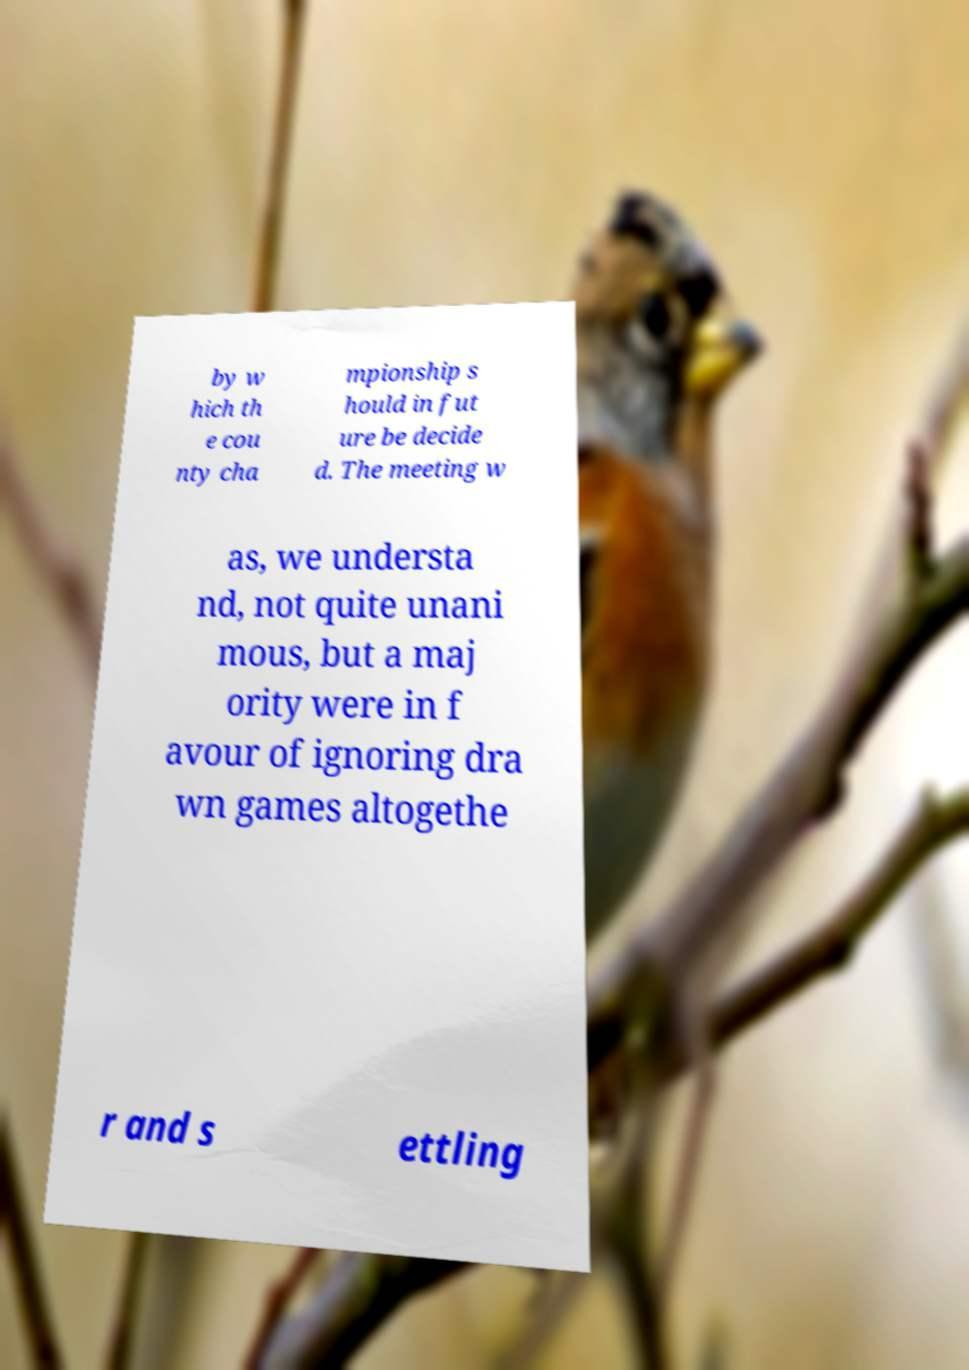There's text embedded in this image that I need extracted. Can you transcribe it verbatim? by w hich th e cou nty cha mpionship s hould in fut ure be decide d. The meeting w as, we understa nd, not quite unani mous, but a maj ority were in f avour of ignoring dra wn games altogethe r and s ettling 